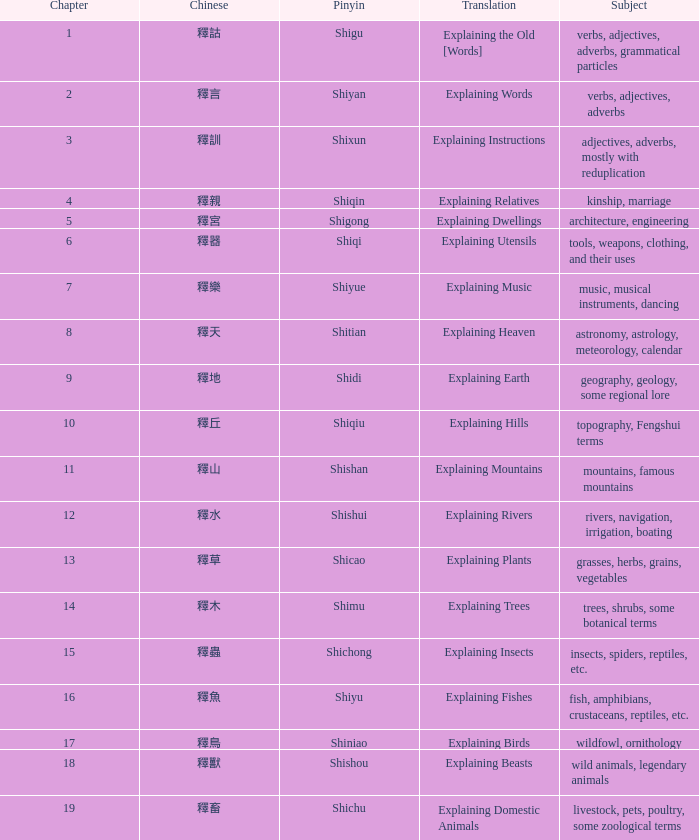Name the highest chapter with chinese of 釋言 2.0. 